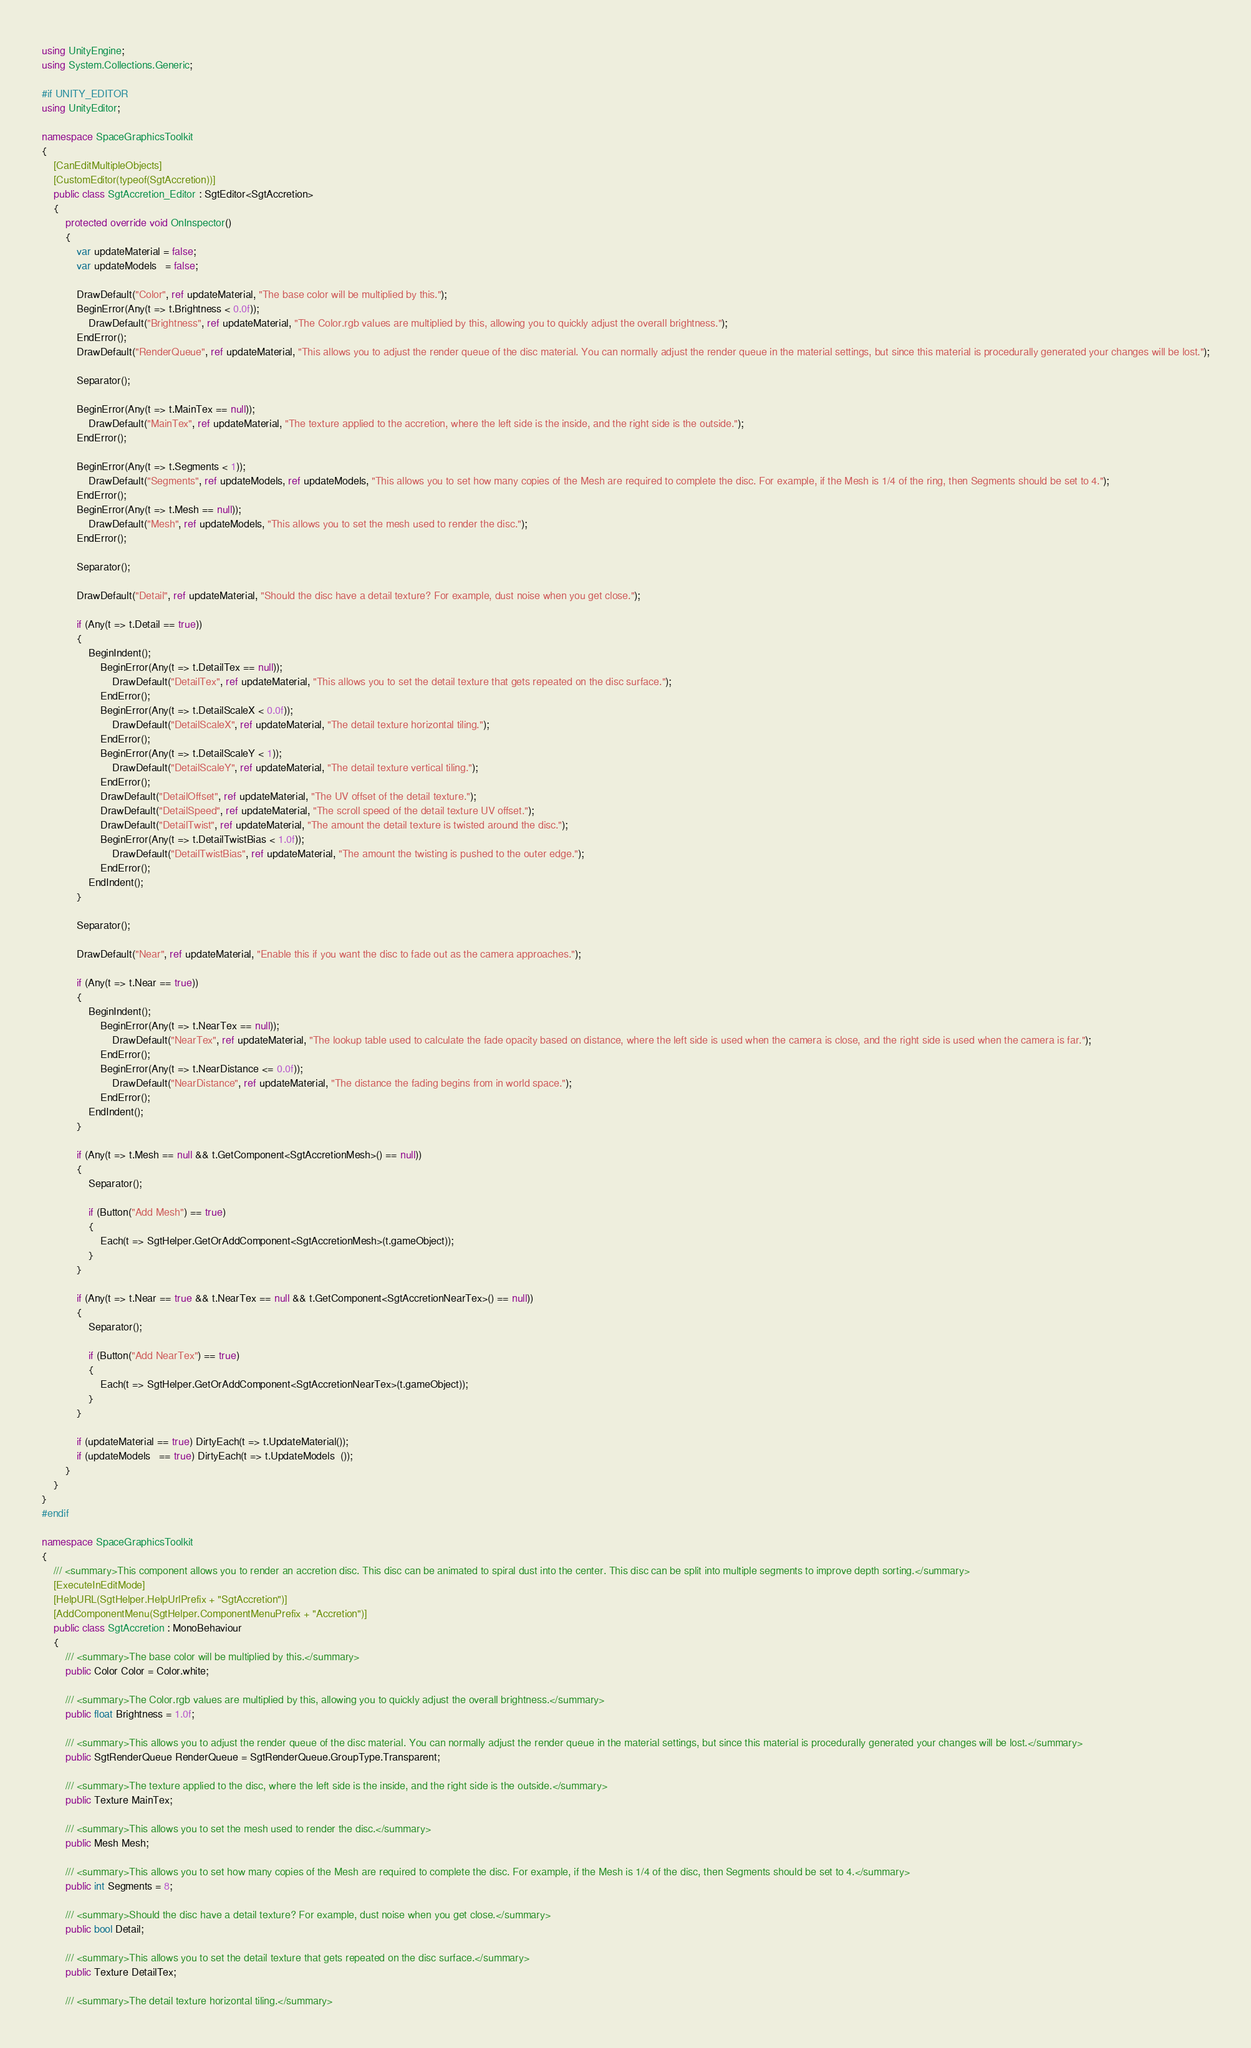Convert code to text. <code><loc_0><loc_0><loc_500><loc_500><_C#_>using UnityEngine;
using System.Collections.Generic;

#if UNITY_EDITOR
using UnityEditor;

namespace SpaceGraphicsToolkit
{
	[CanEditMultipleObjects]
	[CustomEditor(typeof(SgtAccretion))]
	public class SgtAccretion_Editor : SgtEditor<SgtAccretion>
	{
		protected override void OnInspector()
		{
			var updateMaterial = false;
			var updateModels   = false;

			DrawDefault("Color", ref updateMaterial, "The base color will be multiplied by this.");
			BeginError(Any(t => t.Brightness < 0.0f));
				DrawDefault("Brightness", ref updateMaterial, "The Color.rgb values are multiplied by this, allowing you to quickly adjust the overall brightness.");
			EndError();
			DrawDefault("RenderQueue", ref updateMaterial, "This allows you to adjust the render queue of the disc material. You can normally adjust the render queue in the material settings, but since this material is procedurally generated your changes will be lost.");

			Separator();

			BeginError(Any(t => t.MainTex == null));
				DrawDefault("MainTex", ref updateMaterial, "The texture applied to the accretion, where the left side is the inside, and the right side is the outside.");
			EndError();

			BeginError(Any(t => t.Segments < 1));
				DrawDefault("Segments", ref updateModels, ref updateModels, "This allows you to set how many copies of the Mesh are required to complete the disc. For example, if the Mesh is 1/4 of the ring, then Segments should be set to 4.");
			EndError();
			BeginError(Any(t => t.Mesh == null));
				DrawDefault("Mesh", ref updateModels, "This allows you to set the mesh used to render the disc.");
			EndError();

			Separator();

			DrawDefault("Detail", ref updateMaterial, "Should the disc have a detail texture? For example, dust noise when you get close.");

			if (Any(t => t.Detail == true))
			{
				BeginIndent();
					BeginError(Any(t => t.DetailTex == null));
						DrawDefault("DetailTex", ref updateMaterial, "This allows you to set the detail texture that gets repeated on the disc surface.");
					EndError();
					BeginError(Any(t => t.DetailScaleX < 0.0f));
						DrawDefault("DetailScaleX", ref updateMaterial, "The detail texture horizontal tiling.");
					EndError();
					BeginError(Any(t => t.DetailScaleY < 1));
						DrawDefault("DetailScaleY", ref updateMaterial, "The detail texture vertical tiling.");
					EndError();
					DrawDefault("DetailOffset", ref updateMaterial, "The UV offset of the detail texture.");
					DrawDefault("DetailSpeed", ref updateMaterial, "The scroll speed of the detail texture UV offset.");
					DrawDefault("DetailTwist", ref updateMaterial, "The amount the detail texture is twisted around the disc.");
					BeginError(Any(t => t.DetailTwistBias < 1.0f));
						DrawDefault("DetailTwistBias", ref updateMaterial, "The amount the twisting is pushed to the outer edge.");
					EndError();
				EndIndent();
			}

			Separator();

			DrawDefault("Near", ref updateMaterial, "Enable this if you want the disc to fade out as the camera approaches.");

			if (Any(t => t.Near == true))
			{
				BeginIndent();
					BeginError(Any(t => t.NearTex == null));
						DrawDefault("NearTex", ref updateMaterial, "The lookup table used to calculate the fade opacity based on distance, where the left side is used when the camera is close, and the right side is used when the camera is far.");
					EndError();
					BeginError(Any(t => t.NearDistance <= 0.0f));
						DrawDefault("NearDistance", ref updateMaterial, "The distance the fading begins from in world space.");
					EndError();
				EndIndent();
			}

			if (Any(t => t.Mesh == null && t.GetComponent<SgtAccretionMesh>() == null))
			{
				Separator();

				if (Button("Add Mesh") == true)
				{
					Each(t => SgtHelper.GetOrAddComponent<SgtAccretionMesh>(t.gameObject));
				}
			}

			if (Any(t => t.Near == true && t.NearTex == null && t.GetComponent<SgtAccretionNearTex>() == null))
			{
				Separator();

				if (Button("Add NearTex") == true)
				{
					Each(t => SgtHelper.GetOrAddComponent<SgtAccretionNearTex>(t.gameObject));
				}
			}

			if (updateMaterial == true) DirtyEach(t => t.UpdateMaterial());
			if (updateModels   == true) DirtyEach(t => t.UpdateModels  ());
		}
	}
}
#endif

namespace SpaceGraphicsToolkit
{
	/// <summary>This component allows you to render an accretion disc. This disc can be animated to spiral dust into the center. This disc can be split into multiple segments to improve depth sorting.</summary>
	[ExecuteInEditMode]
	[HelpURL(SgtHelper.HelpUrlPrefix + "SgtAccretion")]
	[AddComponentMenu(SgtHelper.ComponentMenuPrefix + "Accretion")]
	public class SgtAccretion : MonoBehaviour
	{
		/// <summary>The base color will be multiplied by this.</summary>
		public Color Color = Color.white;

		/// <summary>The Color.rgb values are multiplied by this, allowing you to quickly adjust the overall brightness.</summary>
		public float Brightness = 1.0f;

		/// <summary>This allows you to adjust the render queue of the disc material. You can normally adjust the render queue in the material settings, but since this material is procedurally generated your changes will be lost.</summary>
		public SgtRenderQueue RenderQueue = SgtRenderQueue.GroupType.Transparent;

		/// <summary>The texture applied to the disc, where the left side is the inside, and the right side is the outside.</summary>
		public Texture MainTex;

		/// <summary>This allows you to set the mesh used to render the disc.</summary>
		public Mesh Mesh;

		/// <summary>This allows you to set how many copies of the Mesh are required to complete the disc. For example, if the Mesh is 1/4 of the disc, then Segments should be set to 4.</summary>
		public int Segments = 8;

		/// <summary>Should the disc have a detail texture? For example, dust noise when you get close.</summary>
		public bool Detail;

		/// <summary>This allows you to set the detail texture that gets repeated on the disc surface.</summary>
		public Texture DetailTex;

		/// <summary>The detail texture horizontal tiling.</summary></code> 